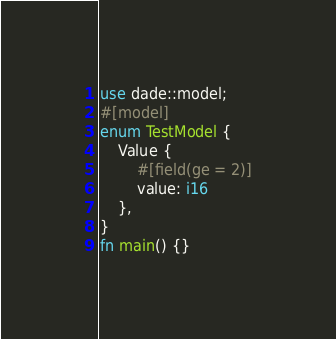Convert code to text. <code><loc_0><loc_0><loc_500><loc_500><_Rust_>use dade::model;
#[model]
enum TestModel {
    Value {
        #[field(ge = 2)]
        value: i16
    },
}
fn main() {}
</code> 